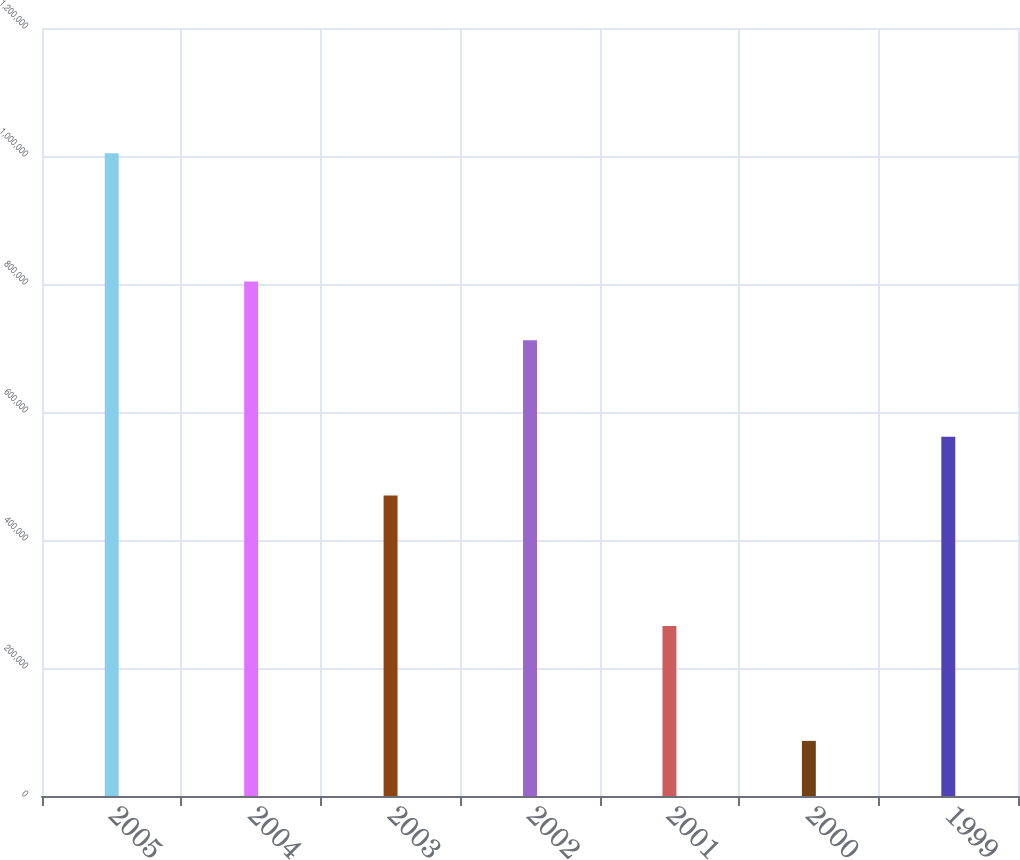Convert chart. <chart><loc_0><loc_0><loc_500><loc_500><bar_chart><fcel>2005<fcel>2004<fcel>2003<fcel>2002<fcel>2001<fcel>2000<fcel>1999<nl><fcel>1.00425e+06<fcel>803860<fcel>469400<fcel>712050<fcel>265800<fcel>86150<fcel>561210<nl></chart> 